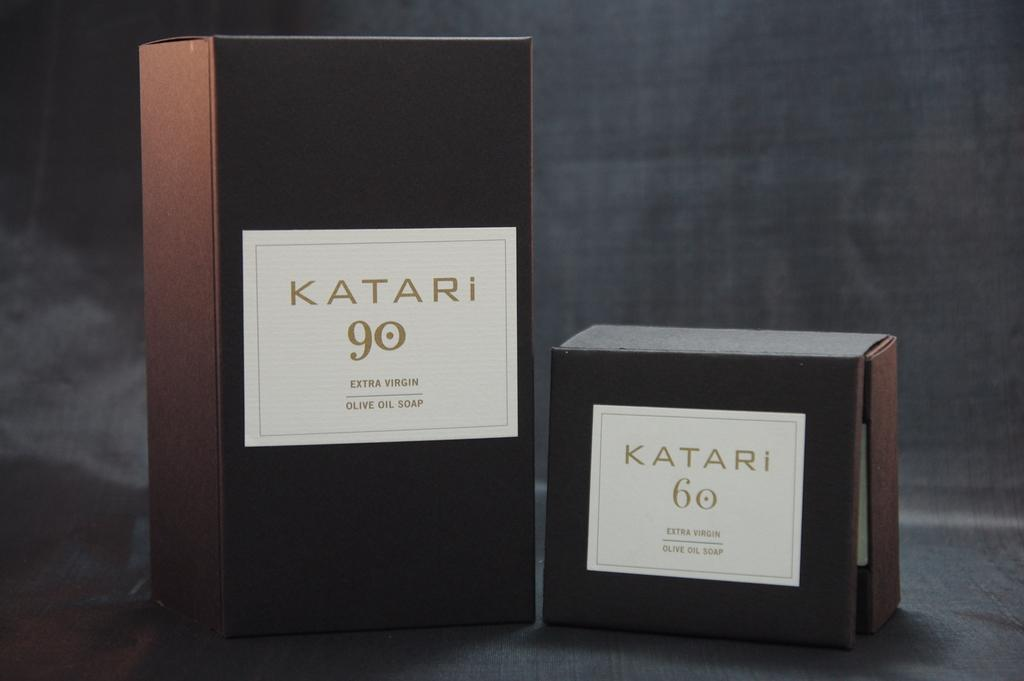<image>
Render a clear and concise summary of the photo. Tall Katari 90 box next to a smaller Katari 60 box. 